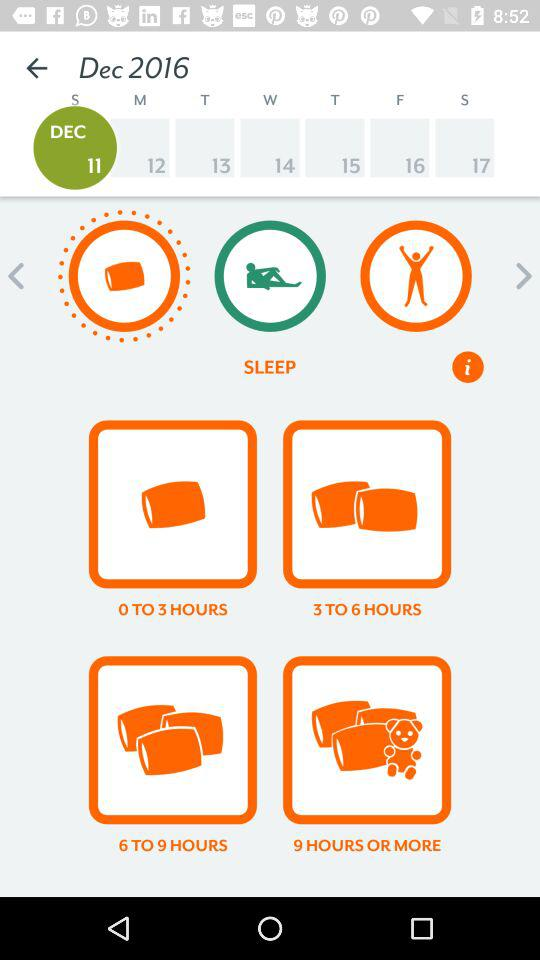Which date is scheduled in December 2016? The scheduled date is December 11, 2016. 